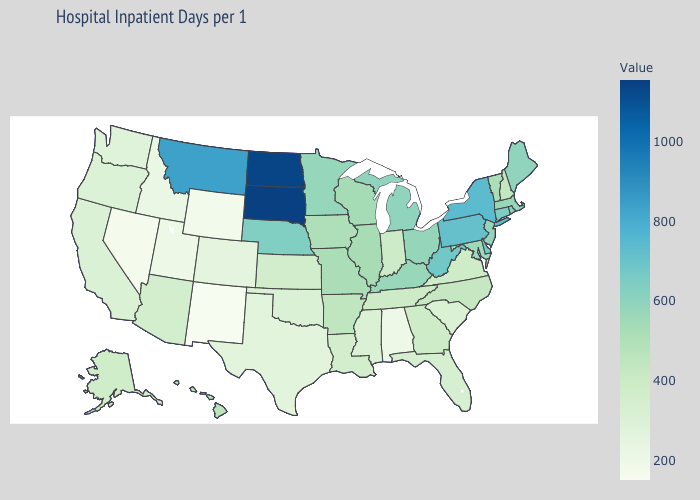Which states have the lowest value in the USA?
Answer briefly. New Mexico. Does New Mexico have a higher value than Illinois?
Quick response, please. No. Which states hav the highest value in the West?
Quick response, please. Montana. Among the states that border Georgia , which have the lowest value?
Keep it brief. Alabama. Which states hav the highest value in the West?
Write a very short answer. Montana. 